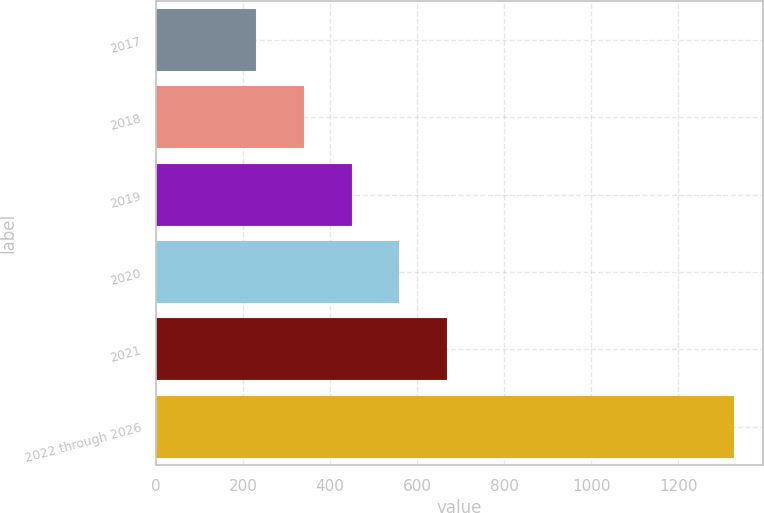<chart> <loc_0><loc_0><loc_500><loc_500><bar_chart><fcel>2017<fcel>2018<fcel>2019<fcel>2020<fcel>2021<fcel>2022 through 2026<nl><fcel>230<fcel>339.7<fcel>449.4<fcel>559.1<fcel>668.8<fcel>1327<nl></chart> 